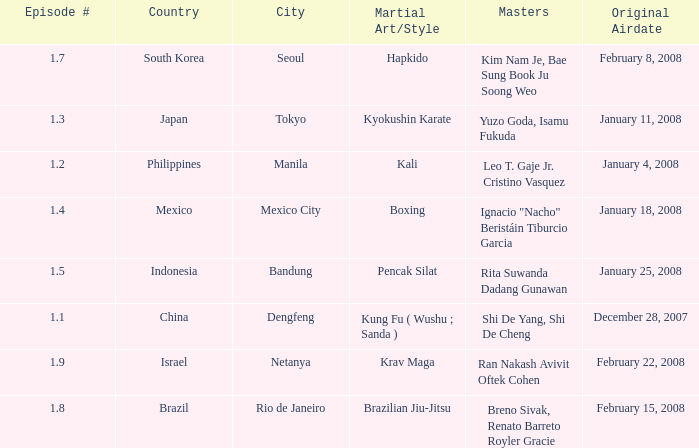Which masters fought in hapkido style? Kim Nam Je, Bae Sung Book Ju Soong Weo. 